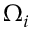Convert formula to latex. <formula><loc_0><loc_0><loc_500><loc_500>\Omega _ { i }</formula> 